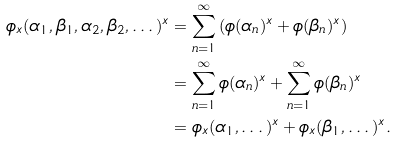<formula> <loc_0><loc_0><loc_500><loc_500>\phi _ { x } ( \alpha _ { 1 } , \beta _ { 1 } , \alpha _ { 2 } , \beta _ { 2 } , \dots ) ^ { x } & = \sum _ { n = 1 } ^ { \infty } \left ( \phi ( \alpha _ { n } ) ^ { x } + \phi ( \beta _ { n } ) ^ { x } \right ) \\ & = \sum _ { n = 1 } ^ { \infty } \phi ( \alpha _ { n } ) ^ { x } + \sum _ { n = 1 } ^ { \infty } \phi ( \beta _ { n } ) ^ { x } \\ & = \phi _ { x } ( \alpha _ { 1 } , \dots ) ^ { x } + \phi _ { x } ( \beta _ { 1 } , \dots ) ^ { x } .</formula> 